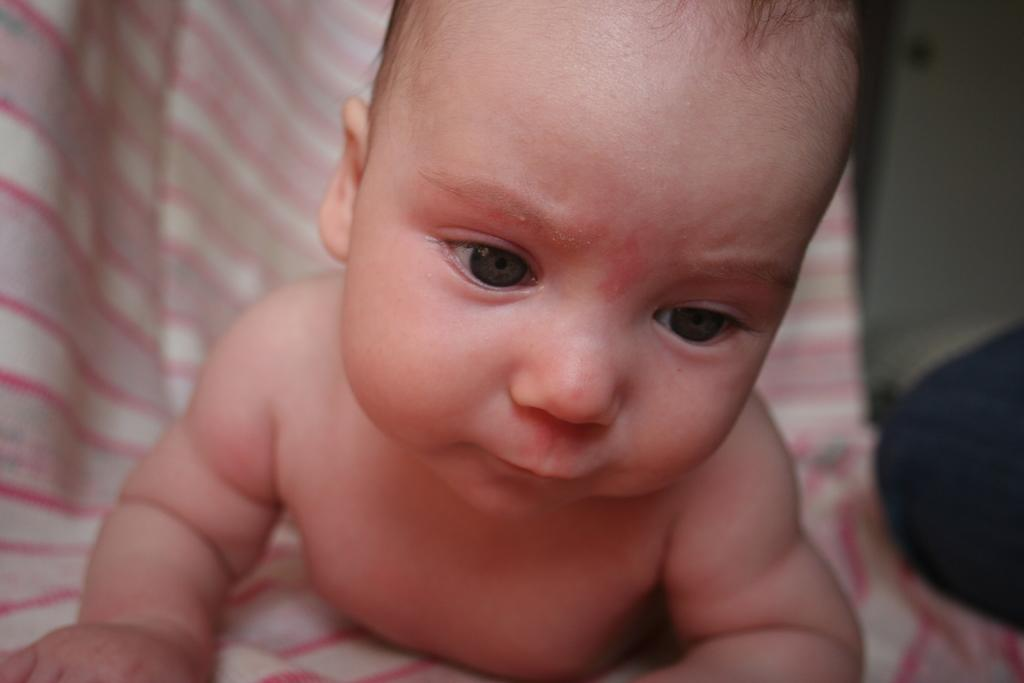What is the main subject of the image? There is a baby in the center of the image. Can you describe the baby's position or posture? The provided facts do not specify the baby's position or posture. Is there anything else in the image besides the baby? The provided facts do not mention any other objects or subjects in the image. What type of holiday is the baby celebrating in the image? There is no indication of a holiday in the image, as it only features a baby in the center. Can you describe the servant attending to the baby in the image? There is no servant present in the image; it only features a baby in the center. 